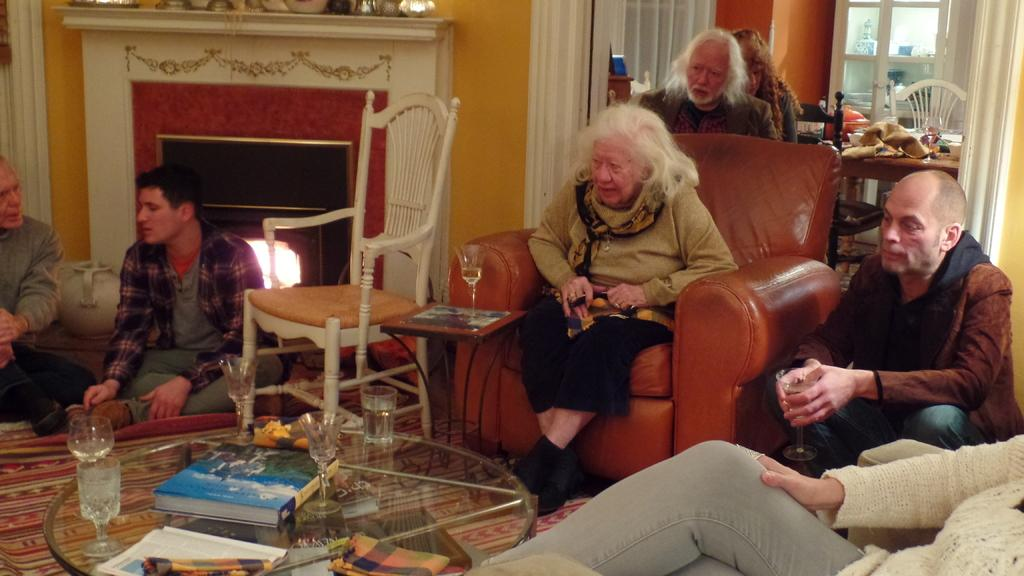How many people are in the image? There is a group of people in the image. What are the people doing in the image? The people are sitting. What is in front of the group of people? There is a glass table in front of the group. What items can be seen on the table? There are glasses and books on the table. What type of jeans is the person wearing in the image? There is no information about the type of jeans worn by anyone in the image. 